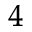<formula> <loc_0><loc_0><loc_500><loc_500>^ { 4 }</formula> 